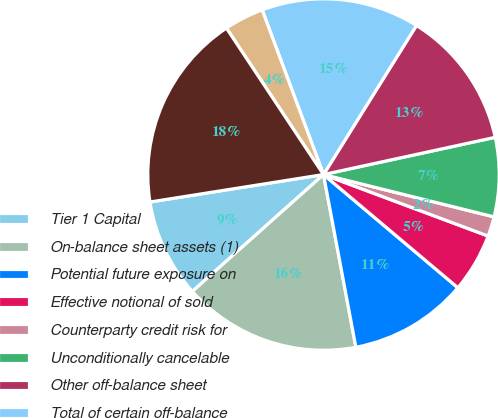Convert chart. <chart><loc_0><loc_0><loc_500><loc_500><pie_chart><fcel>Tier 1 Capital<fcel>On-balance sheet assets (1)<fcel>Potential future exposure on<fcel>Effective notional of sold<fcel>Counterparty credit risk for<fcel>Unconditionally cancelable<fcel>Other off-balance sheet<fcel>Total of certain off-balance<fcel>Less Tier 1 Capital deductions<fcel>Total Leverage Exposure<nl><fcel>9.09%<fcel>16.36%<fcel>10.91%<fcel>5.45%<fcel>1.82%<fcel>7.27%<fcel>12.73%<fcel>14.55%<fcel>3.64%<fcel>18.18%<nl></chart> 